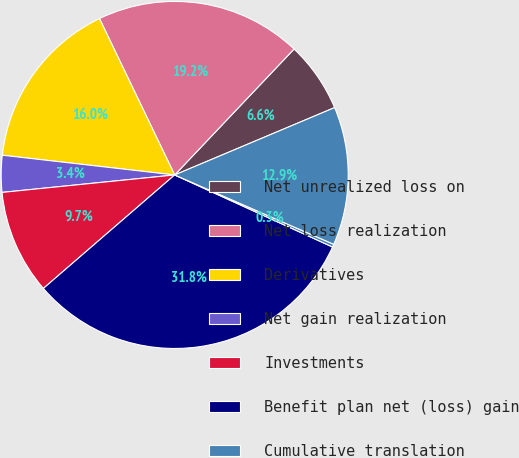Convert chart to OTSL. <chart><loc_0><loc_0><loc_500><loc_500><pie_chart><fcel>Net unrealized loss on<fcel>Net loss realization<fcel>Derivatives<fcel>Net gain realization<fcel>Investments<fcel>Benefit plan net (loss) gain<fcel>Cumulative translation<fcel>Net unrealized gain on<nl><fcel>6.58%<fcel>19.21%<fcel>16.05%<fcel>3.42%<fcel>9.74%<fcel>31.84%<fcel>0.27%<fcel>12.89%<nl></chart> 